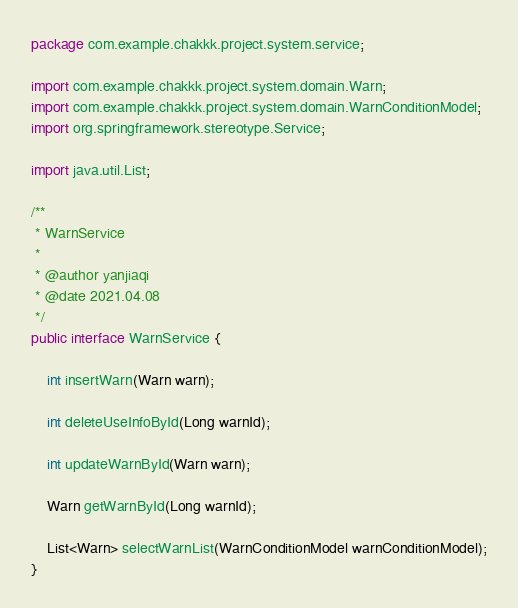Convert code to text. <code><loc_0><loc_0><loc_500><loc_500><_Java_>package com.example.chakkk.project.system.service;

import com.example.chakkk.project.system.domain.Warn;
import com.example.chakkk.project.system.domain.WarnConditionModel;
import org.springframework.stereotype.Service;

import java.util.List;

/**
 * WarnService
 *
 * @author yanjiaqi
 * @date 2021.04.08
 */
public interface WarnService {

    int insertWarn(Warn warn);

    int deleteUseInfoById(Long warnId);

    int updateWarnById(Warn warn);

    Warn getWarnById(Long warnId);

    List<Warn> selectWarnList(WarnConditionModel warnConditionModel);
}
</code> 